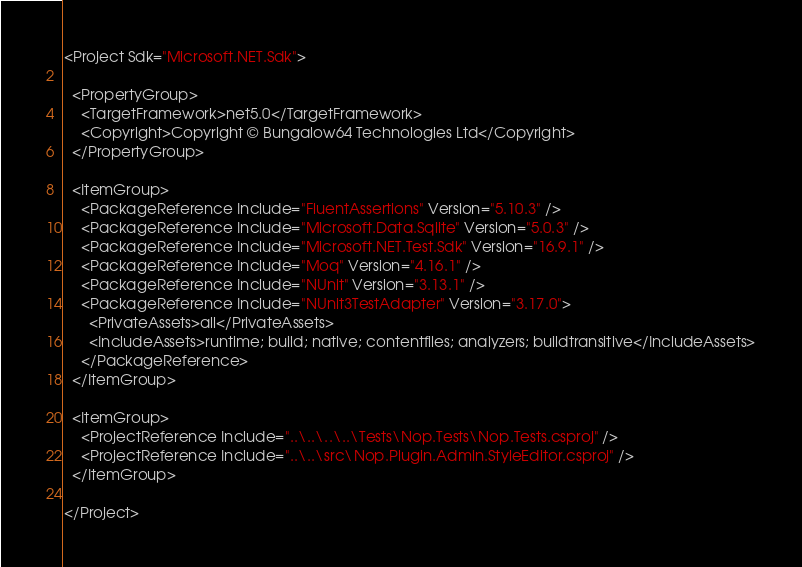Convert code to text. <code><loc_0><loc_0><loc_500><loc_500><_XML_><Project Sdk="Microsoft.NET.Sdk">

  <PropertyGroup>
    <TargetFramework>net5.0</TargetFramework>
    <Copyright>Copyright © Bungalow64 Technologies Ltd</Copyright>
  </PropertyGroup>

  <ItemGroup>
    <PackageReference Include="FluentAssertions" Version="5.10.3" />
    <PackageReference Include="Microsoft.Data.Sqlite" Version="5.0.3" />
    <PackageReference Include="Microsoft.NET.Test.Sdk" Version="16.9.1" />
    <PackageReference Include="Moq" Version="4.16.1" />
    <PackageReference Include="NUnit" Version="3.13.1" />
    <PackageReference Include="NUnit3TestAdapter" Version="3.17.0">
      <PrivateAssets>all</PrivateAssets>
      <IncludeAssets>runtime; build; native; contentfiles; analyzers; buildtransitive</IncludeAssets>
    </PackageReference>
  </ItemGroup>

  <ItemGroup>
    <ProjectReference Include="..\..\..\..\Tests\Nop.Tests\Nop.Tests.csproj" />
    <ProjectReference Include="..\..\src\Nop.Plugin.Admin.StyleEditor.csproj" />
  </ItemGroup>

</Project>
</code> 